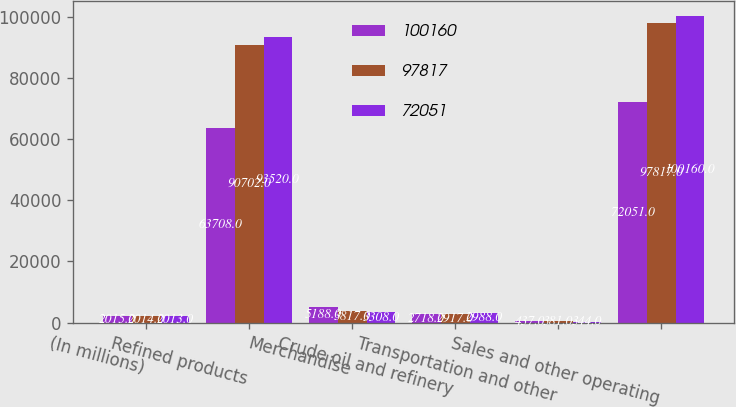<chart> <loc_0><loc_0><loc_500><loc_500><stacked_bar_chart><ecel><fcel>(In millions)<fcel>Refined products<fcel>Merchandise<fcel>Crude oil and refinery<fcel>Transportation and other<fcel>Sales and other operating<nl><fcel>100160<fcel>2015<fcel>63708<fcel>5188<fcel>2718<fcel>437<fcel>72051<nl><fcel>97817<fcel>2014<fcel>90702<fcel>3817<fcel>2917<fcel>381<fcel>97817<nl><fcel>72051<fcel>2013<fcel>93520<fcel>3308<fcel>2988<fcel>344<fcel>100160<nl></chart> 